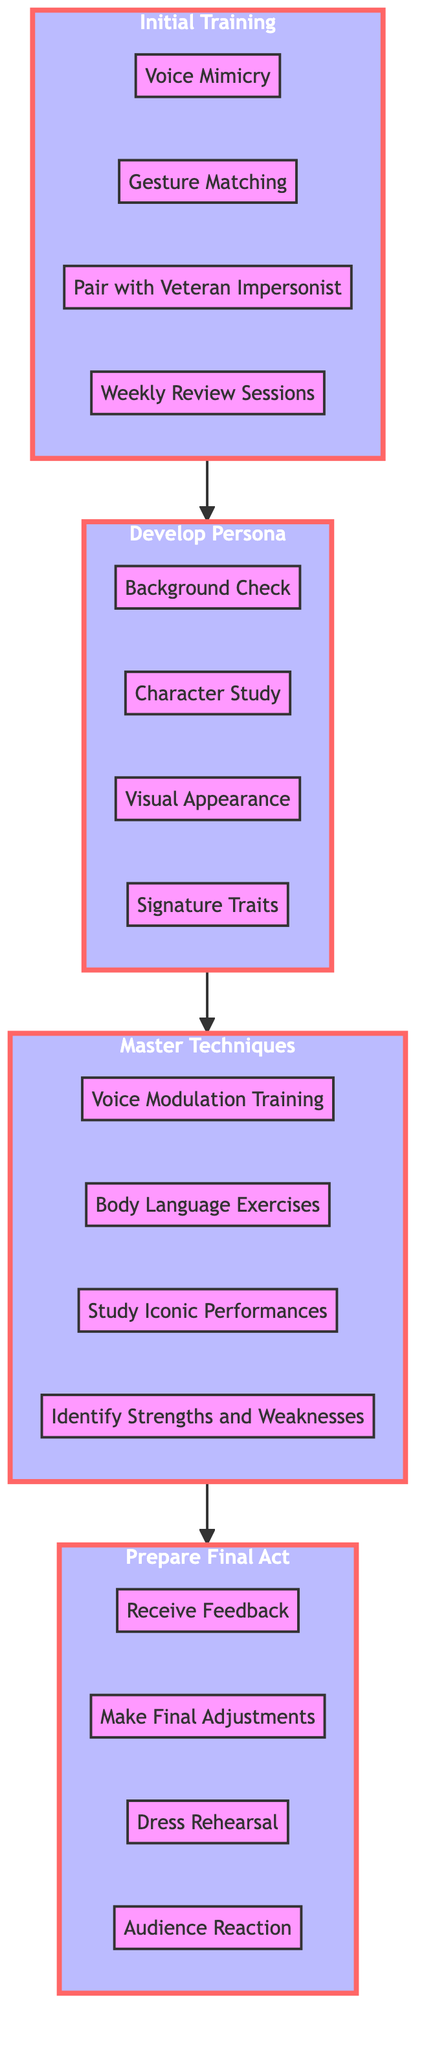What is the top node of the flowchart? The flowchart starts with "Prepare Final Act," which is the final stage of the process and located at the top of the flowchart.
Answer: Prepare Final Act How many nodes are in the "Master Techniques" stage? The "Master Techniques" stage includes four nodes: Voice Modulation Training, Body Language Exercises, Study Iconic Performances, and Identify Strengths and Weaknesses.
Answer: 4 Which node connects "Develop Persona" to "Master Techniques"? "Develop Persona" flows into "Master Techniques," with the specific connection being the end of the "Develop" subgraph and the start of the "Master" subgraph, linking these two distinct stages.
Answer: Master Techniques What are the two sub-nodes under "Initial Training"? The "Initial Training" stage has two sub-nodes listed as: Voice Mimicry and Gesture Matching.
Answer: Voice Mimicry, Gesture Matching What is the first node that emerging talents encounter in the flowchart? The process begins with the "Initial Training" stage, where emerging talents start their impersonation journey by learning the basics of voice mimicry and gesture matching.
Answer: Initial Training How many stages are there in the flowchart? The flowchart has four distinct stages: Initial Training, Develop Persona, Master Techniques, and Prepare Final Act, each representing an important phase in guiding emerging talents.
Answer: 4 What is required after "Analyze" in the "Master Techniques" stage? After "Analyze," the next stage is "Prepare Final Act," where emerging talents focus on validating their act and testing performance, indicating a progression towards execution.
Answer: Prepare Final Act What kind of exercises are performed in the "Master Techniques" stage? The "Master Techniques" stage includes two types of exercises: Voice Modulation Training and Body Language Exercises, which are crucial for developing impersonation skills.
Answer: Voice Modulation Training, Body Language Exercises Which node leads to the feedback stage? The node "Receive Feedback" leads to the feedback stage, which is a part of the "Prepare Final Act" phase where actors assess their performance.
Answer: Receive Feedback 